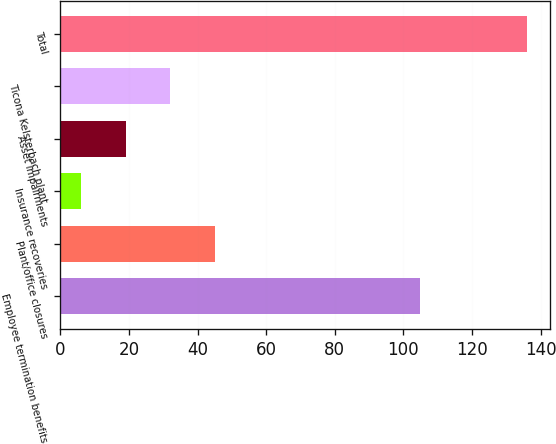<chart> <loc_0><loc_0><loc_500><loc_500><bar_chart><fcel>Employee termination benefits<fcel>Plant/office closures<fcel>Insurance recoveries<fcel>Asset impairments<fcel>Ticona Kelsterbach plant<fcel>Total<nl><fcel>105<fcel>45<fcel>6<fcel>19<fcel>32<fcel>136<nl></chart> 